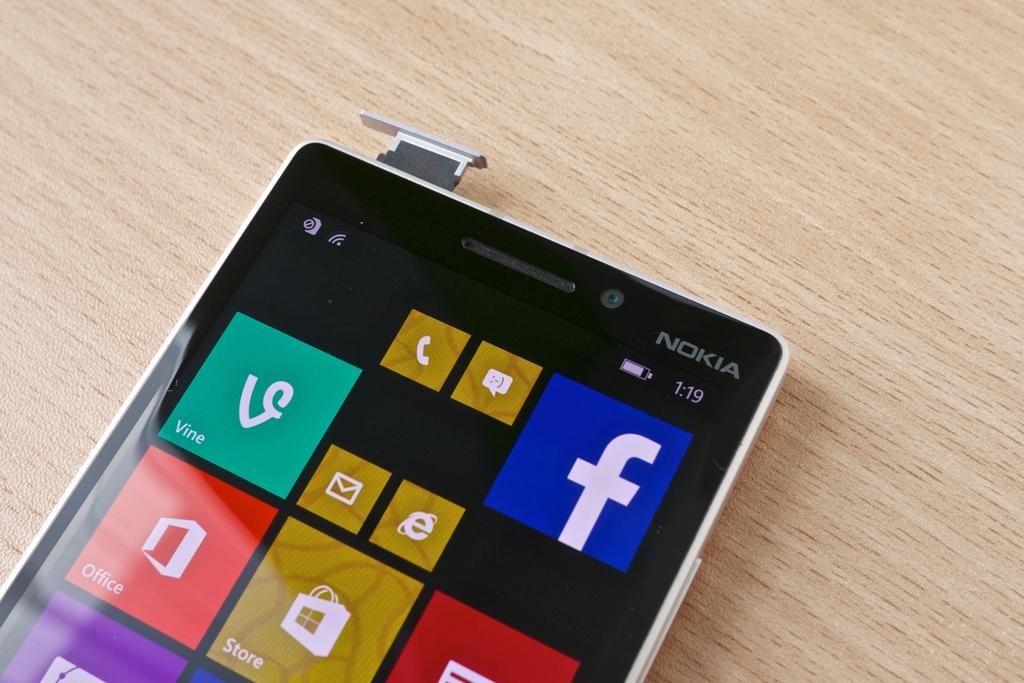<image>
Create a compact narrative representing the image presented. a close up of a Nokia phone on a wood surface 